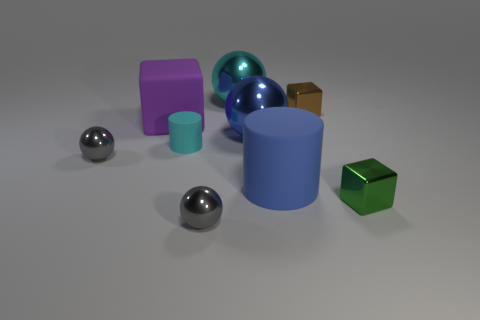Subtract 2 balls. How many balls are left? 2 Add 1 tiny green objects. How many objects exist? 10 Subtract all cylinders. How many objects are left? 7 Subtract 0 yellow cylinders. How many objects are left? 9 Subtract all purple rubber spheres. Subtract all brown cubes. How many objects are left? 8 Add 3 brown metal objects. How many brown metal objects are left? 4 Add 8 brown blocks. How many brown blocks exist? 9 